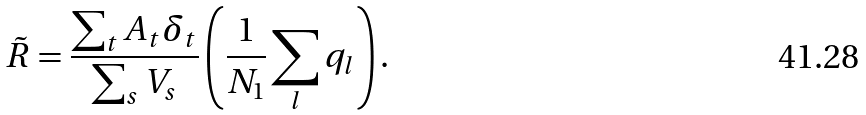Convert formula to latex. <formula><loc_0><loc_0><loc_500><loc_500>\tilde { R } = \frac { \sum _ { t } A _ { t } { \delta } _ { t } } { \sum _ { s } V _ { s } } \left ( \frac { 1 } { N _ { 1 } } \sum _ { l } q _ { l } \right ) .</formula> 